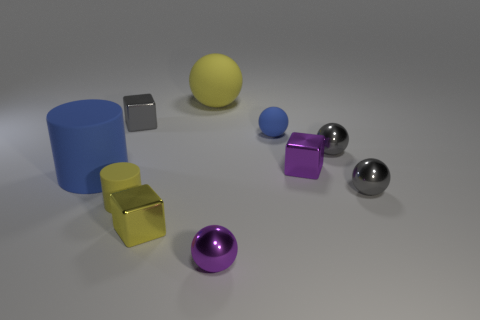Is the number of things that are in front of the big blue thing greater than the number of gray spheres?
Keep it short and to the point. Yes. There is a purple thing behind the tiny yellow matte thing; does it have the same shape as the tiny blue object?
Your response must be concise. No. How many objects are big green rubber things or tiny yellow matte cylinders left of the small rubber sphere?
Your response must be concise. 1. What is the size of the yellow thing that is both in front of the big matte ball and behind the tiny yellow metal thing?
Ensure brevity in your answer.  Small. Is the number of big yellow objects in front of the big yellow sphere greater than the number of gray metal balls in front of the tiny yellow rubber object?
Offer a very short reply. No. Does the large blue rubber object have the same shape as the metal thing to the left of the tiny yellow rubber cylinder?
Offer a terse response. No. How many other things are there of the same shape as the yellow metallic thing?
Keep it short and to the point. 2. The tiny metallic cube that is both behind the big blue cylinder and in front of the small gray cube is what color?
Make the answer very short. Purple. What is the color of the tiny rubber ball?
Make the answer very short. Blue. Do the small cylinder and the blue thing to the right of the blue rubber cylinder have the same material?
Provide a short and direct response. Yes. 